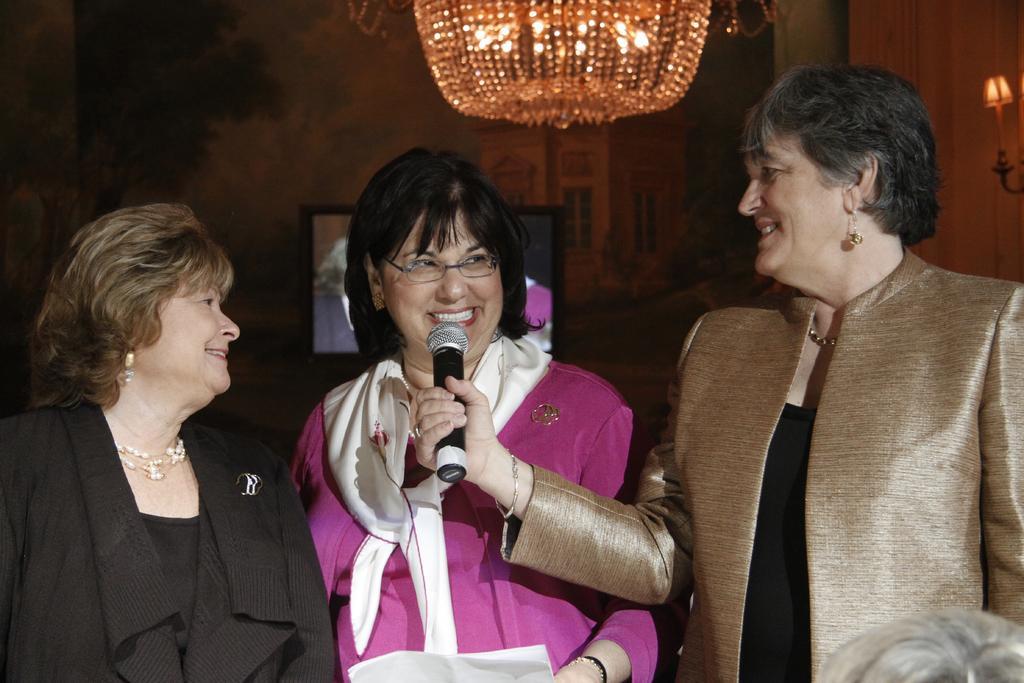In one or two sentences, can you explain what this image depicts? In the image in the center, we can see three persons standing and smiling, which we can see on their faces. And the right side person holding the microphone. in the background there is a wall, monitor, lights and a few other objects. 